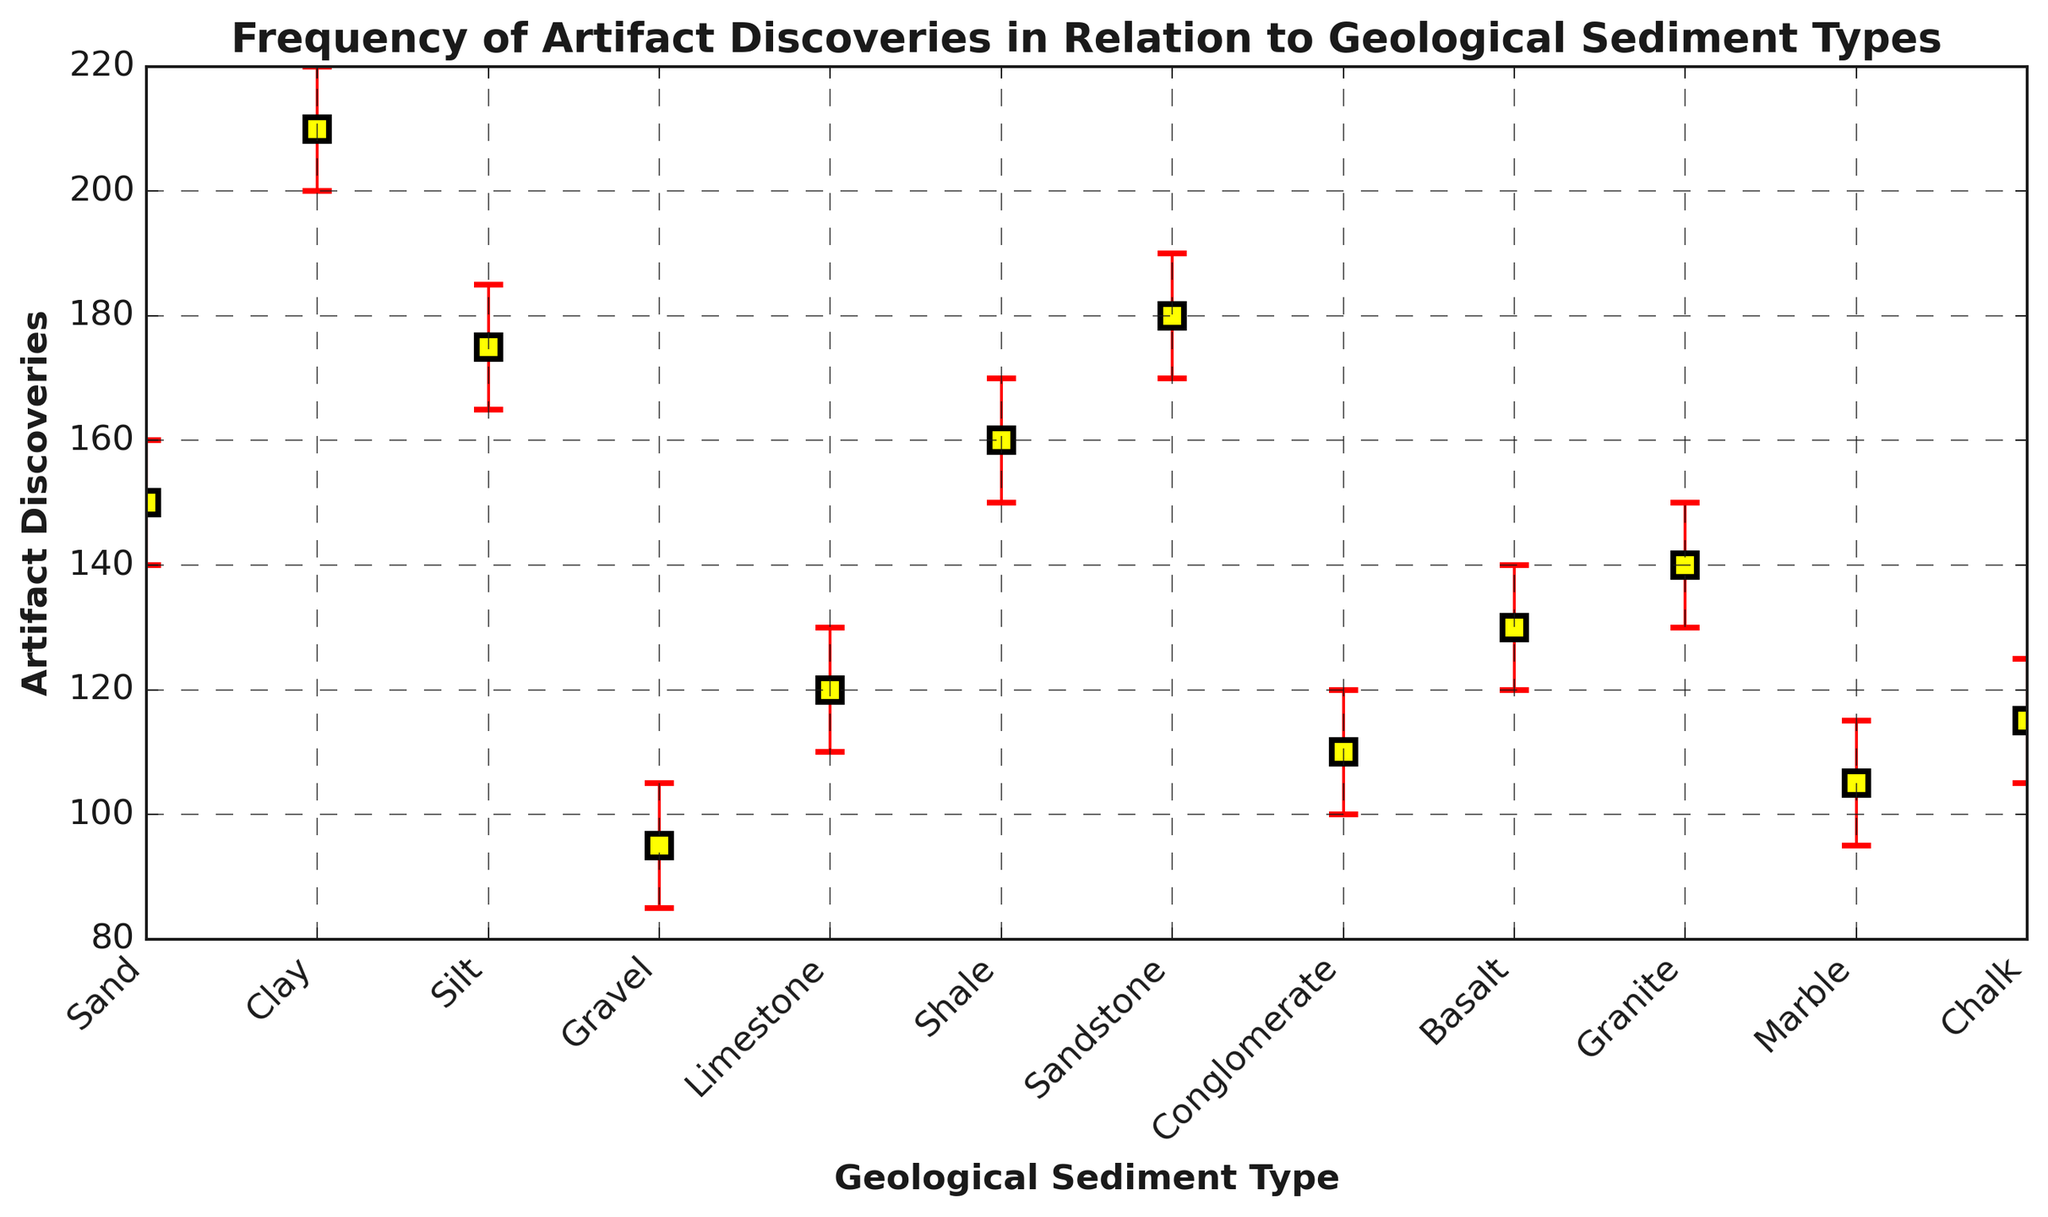What sediment type has the highest frequency of artifact discoveries? The frequency of artifact discoveries is highest for the geological sediment type with the tallest mark. From the plot, the tallest mark corresponds to "Clay" sediment.
Answer: Clay What sediment type has the lowest frequency of artifact discoveries? The frequency of artifact discoveries is lowest for the geological sediment type with the shortest mark. From the plot, the shortest mark corresponds to "Gravel" sediment.
Answer: Gravel Which sediment types have artifact discoveries within the confidence interval of 100-130? We need to identify the sediment types that have both the lower and upper confidence intervals within 100 to 130. From the plot, the sediments "Limestone," "Conglomerate," "Basalt," "Granite," "Marble," and "Chalk" fit this criterion.
Answer: Limestone, Conglomerate, Basalt, Granite, Marble, Chalk What is the average frequency of artifact discoveries for "Sand," "Clay," and "Shale"? The frequencies for "Sand," "Clay," and "Shale" are 150, 210, and 160, respectively. The average is calculated as (150 + 210 + 160) / 3.
Answer: 173.33 How does artifact discovery frequency in "Sandstone" compare to "Silt"? The frequencies for "Sandstone" and "Silt" are 180 and 175, respectively. Comparing them by simple subtraction: 180 - 175. Sandstone has a slightly higher frequency.
Answer: Sandstone has 5 more discoveries than Silt What sediment type has artifact discoveries close to 120 within its confidence interval? From the confidence intervals on the plot, the "Basalt" sediment type has a discovery frequency of 130, which is within the confidence interval range of 120-140. "Limestone" also exactly matches this condition.
Answer: Limestone Which sediment type shows the most uncertainty in artifact discoveries? Higher uncertainty will be indicated by a larger error bar. The widest error interval is for "Clay," as it spans from 200 to 220.
Answer: Clay How do the artifact discoveries in “Silt” compare to those in “Sandstone” in terms of their confidence intervals? We compare the ranges of their confidence intervals: "Silt" (165-185) and "Sandstone" (170-190). Both intervals overlap significantly.
Answer: Overlapping confidence intervals Which sediment type has a narrower confidence interval for artifact discoveries: "Granite" or "Marble"? To determine which sediment has a narrower interval, compare the range size: "Granite" (130-150) and "Marble" (95-115). Both ranges are 20.
Answer: Same interval size 